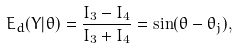Convert formula to latex. <formula><loc_0><loc_0><loc_500><loc_500>E _ { d } ( Y | \theta ) = \frac { I _ { 3 } - I _ { 4 } } { I _ { 3 } + I _ { 4 } } = \sin ( \theta - \theta _ { j } ) ,</formula> 